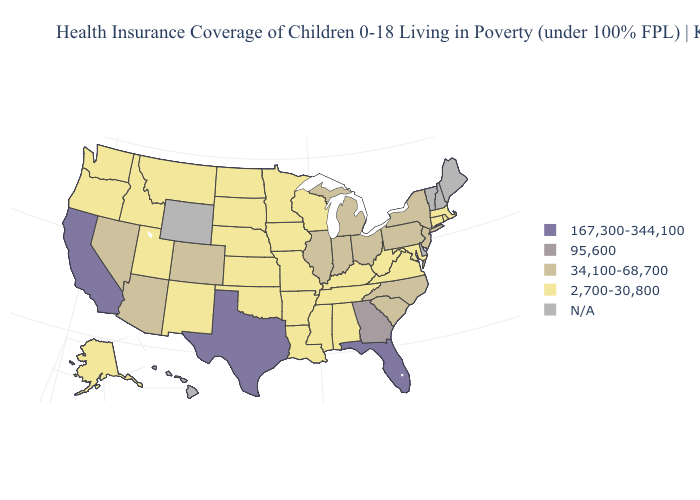Name the states that have a value in the range N/A?
Concise answer only. Delaware, Hawaii, Maine, New Hampshire, Vermont, Wyoming. Which states have the lowest value in the USA?
Give a very brief answer. Alabama, Alaska, Arkansas, Connecticut, Idaho, Iowa, Kansas, Kentucky, Louisiana, Maryland, Massachusetts, Minnesota, Mississippi, Missouri, Montana, Nebraska, New Mexico, North Dakota, Oklahoma, Oregon, Rhode Island, South Dakota, Tennessee, Utah, Virginia, Washington, West Virginia, Wisconsin. Name the states that have a value in the range N/A?
Quick response, please. Delaware, Hawaii, Maine, New Hampshire, Vermont, Wyoming. Name the states that have a value in the range 167,300-344,100?
Write a very short answer. California, Florida, Texas. How many symbols are there in the legend?
Concise answer only. 5. Is the legend a continuous bar?
Short answer required. No. What is the value of New Jersey?
Keep it brief. 34,100-68,700. Which states have the highest value in the USA?
Write a very short answer. California, Florida, Texas. What is the lowest value in states that border Nebraska?
Concise answer only. 2,700-30,800. Name the states that have a value in the range N/A?
Short answer required. Delaware, Hawaii, Maine, New Hampshire, Vermont, Wyoming. Among the states that border Connecticut , does New York have the highest value?
Short answer required. Yes. Which states have the lowest value in the USA?
Write a very short answer. Alabama, Alaska, Arkansas, Connecticut, Idaho, Iowa, Kansas, Kentucky, Louisiana, Maryland, Massachusetts, Minnesota, Mississippi, Missouri, Montana, Nebraska, New Mexico, North Dakota, Oklahoma, Oregon, Rhode Island, South Dakota, Tennessee, Utah, Virginia, Washington, West Virginia, Wisconsin. Among the states that border Illinois , which have the highest value?
Quick response, please. Indiana. Name the states that have a value in the range 95,600?
Concise answer only. Georgia. Name the states that have a value in the range 2,700-30,800?
Be succinct. Alabama, Alaska, Arkansas, Connecticut, Idaho, Iowa, Kansas, Kentucky, Louisiana, Maryland, Massachusetts, Minnesota, Mississippi, Missouri, Montana, Nebraska, New Mexico, North Dakota, Oklahoma, Oregon, Rhode Island, South Dakota, Tennessee, Utah, Virginia, Washington, West Virginia, Wisconsin. 